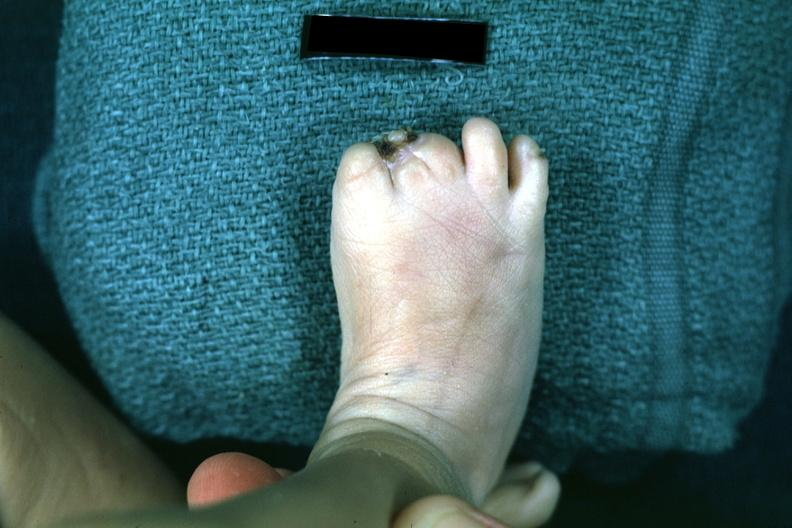re arachnodactyly present?
Answer the question using a single word or phrase. No 